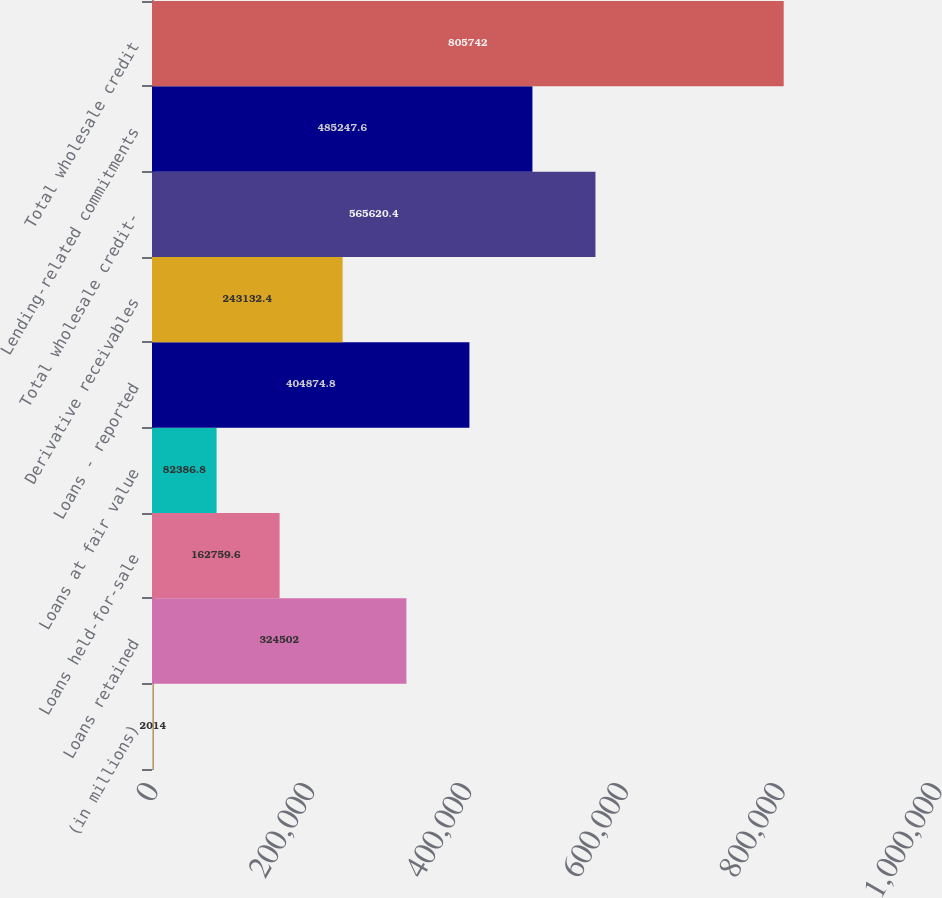Convert chart. <chart><loc_0><loc_0><loc_500><loc_500><bar_chart><fcel>(in millions)<fcel>Loans retained<fcel>Loans held-for-sale<fcel>Loans at fair value<fcel>Loans - reported<fcel>Derivative receivables<fcel>Total wholesale credit-<fcel>Lending-related commitments<fcel>Total wholesale credit<nl><fcel>2014<fcel>324502<fcel>162760<fcel>82386.8<fcel>404875<fcel>243132<fcel>565620<fcel>485248<fcel>805742<nl></chart> 